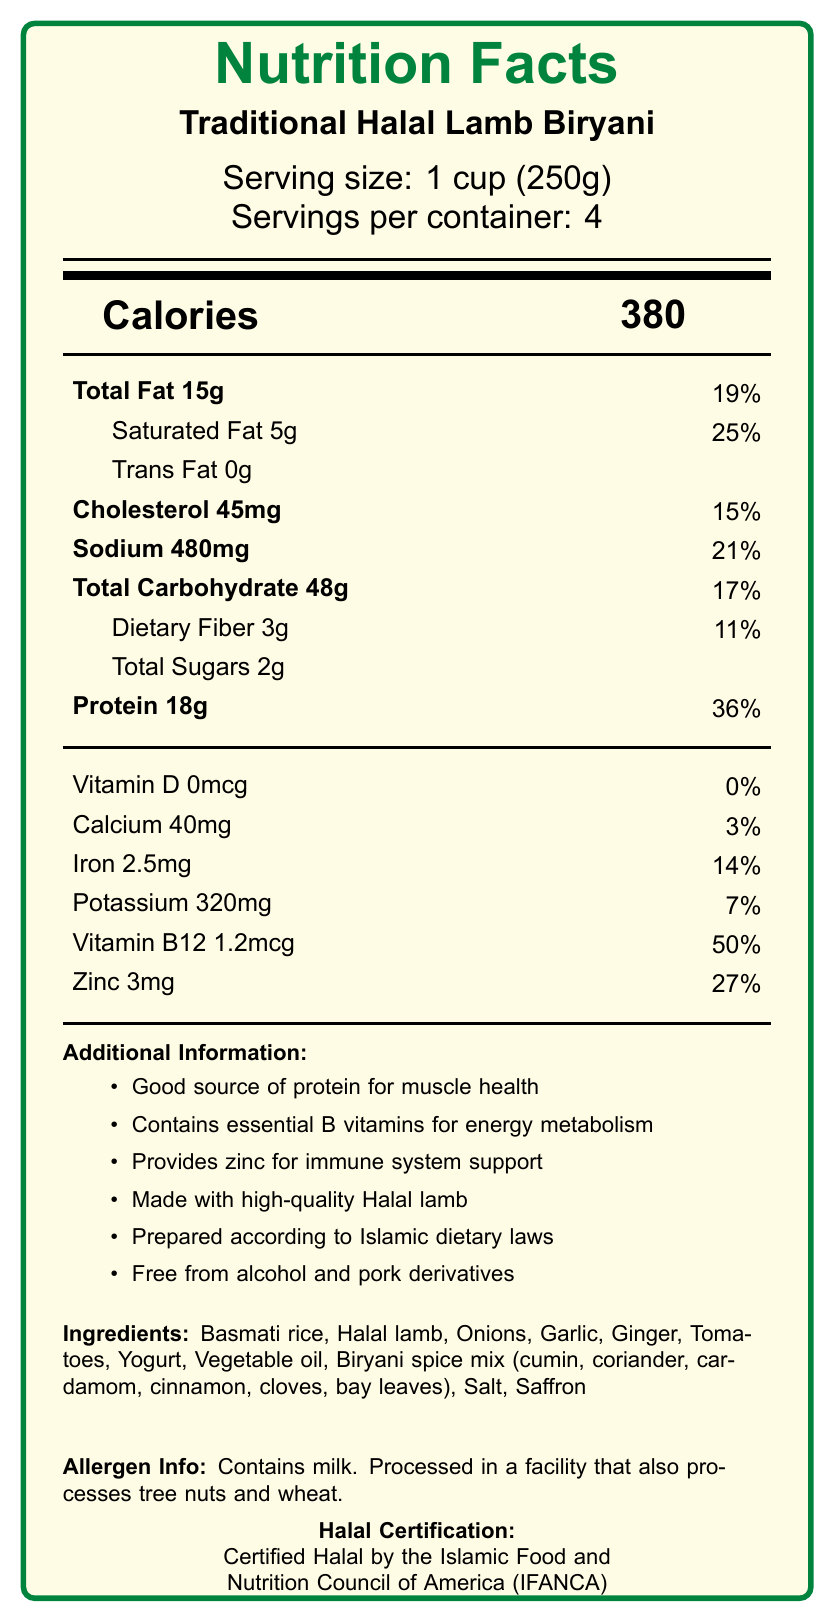what is the serving size of Traditional Halal Lamb Biryani? The serving size is explicitly mentioned near the top of the document.
Answer: 1 cup (250g) how many calories are in one serving? The document states that each serving contains 380 calories.
Answer: 380 what percentage of daily value does the saturated fat in one serving represent? The document indicates that one serving has 5g of saturated fat, which is 25% of the daily value.
Answer: 25% what is the main source of protein in this meal? The ingredients list includes Halal lamb, which is known to be a high source of protein.
Answer: Halal lamb how does the sodium content per serving compare to the daily value? The document states that one serving contains 480mg of sodium, which is 21% of the daily value.
Answer: 21% which vitamin is present at 50% of the daily value? The document states that each serving contains 1.2mcg of Vitamin B12, which is 50% of the daily value.
Answer: Vitamin B12 which of the following ingredients is not part of the Traditional Halal Lamb Biryani? A. Onions B. Saffron C. Cheese D. Garlic The ingredients list does not include cheese.
Answer: C what is the total amount of dietary fiber in one container of this product? A. 3g B. 6g C. 9g D. 12g Each serving has 3g of dietary fiber and there are 4 servings per container, thus totaling 12g.
Answer: D does this product contain any trans fat? The document clearly states that the product contains 0g of trans fat.
Answer: No summarize the document’s main idea in one sentence. The summary captures the key aspects like nutritional information and Halal certification provided in the document.
Answer: The document provides nutritional information for Traditional Halal Lamb Biryani, highlighting its health benefits and adherence to Islamic dietary laws. which ingredient provides the majority of carbohydrates in this meal? The document lists the ingredients but does not specify which one provides the majority of carbohydrates.
Answer: Not enough information which mineral present in this meal supports the immune system? According to the additional information section, zinc supports the immune system.
Answer: Zinc can you determine the fat content from the vegetable oil used in the recipe? The document lists vegetable oil as an ingredient but does not provide its specific fat content separately.
Answer: No 